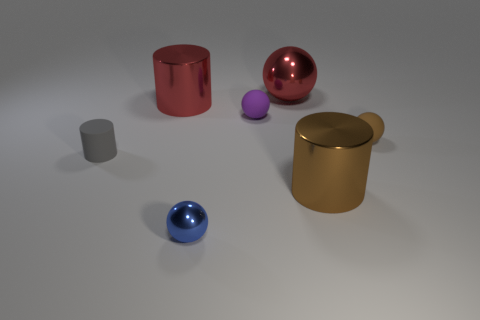Subtract all blue spheres. How many spheres are left? 3 Add 2 large cyan rubber blocks. How many objects exist? 9 Subtract all green balls. Subtract all red cylinders. How many balls are left? 4 Subtract all balls. How many objects are left? 3 Subtract 1 brown cylinders. How many objects are left? 6 Subtract all brown shiny objects. Subtract all purple spheres. How many objects are left? 5 Add 4 large balls. How many large balls are left? 5 Add 7 small purple matte balls. How many small purple matte balls exist? 8 